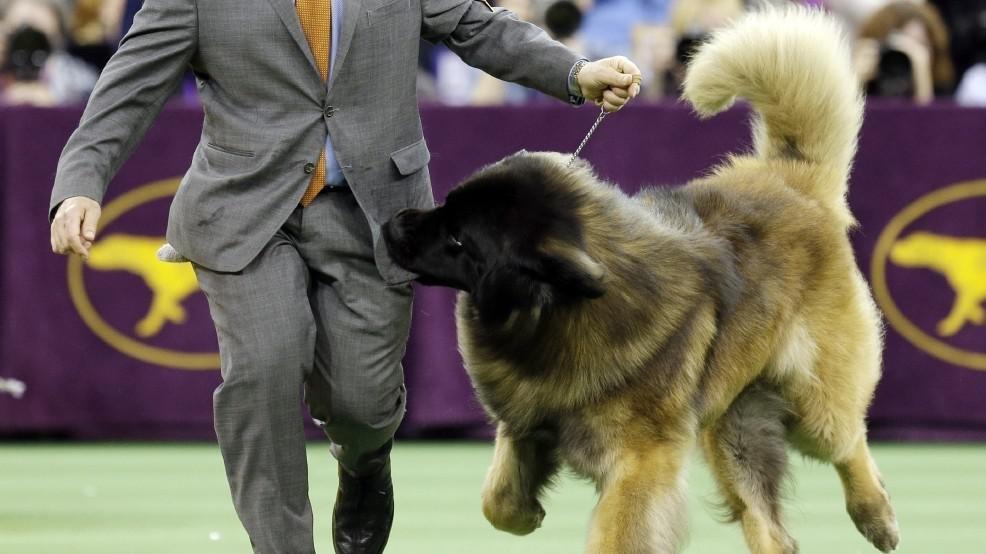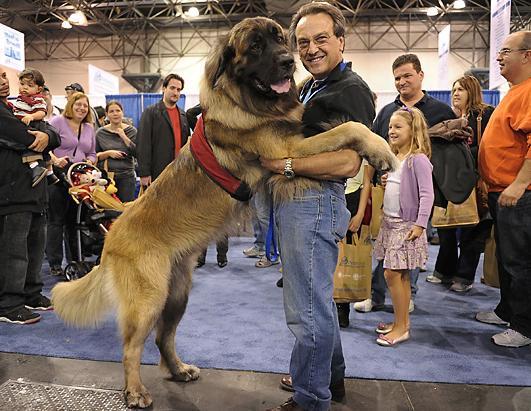The first image is the image on the left, the second image is the image on the right. Given the left and right images, does the statement "Exactly one image, the one on the left, shows a dog tugging on the pocket of its handler at a dog show, and the handler is wearing a brownish-yellow necktie." hold true? Answer yes or no. Yes. The first image is the image on the left, the second image is the image on the right. For the images shown, is this caption "There are more than two dogs visible." true? Answer yes or no. No. 